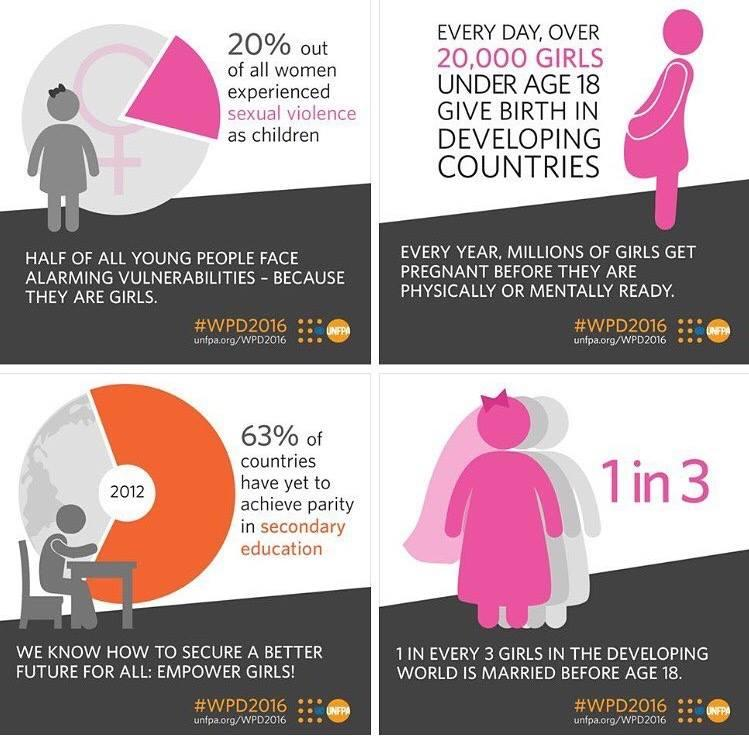List a handful of essential elements in this visual. The pie chart mentions the year 2012. Thirty-seven percent of countries have achieved parity in secondary education. It is estimated that in a developing country, 33% of girls are married before the age of 18. Research indicates that girls are physically and mentally ready to become pregnant by the age of 18. 